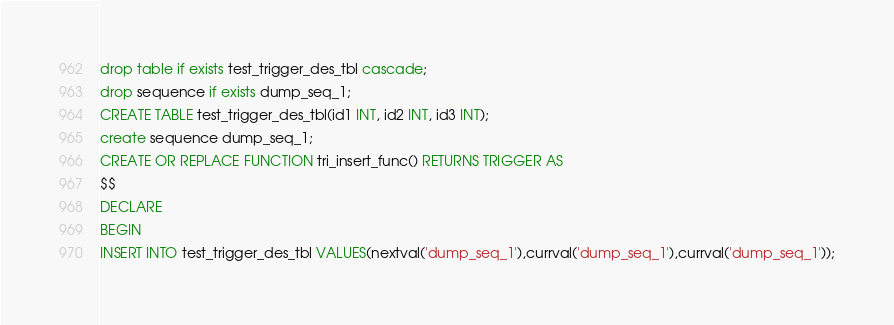Convert code to text. <code><loc_0><loc_0><loc_500><loc_500><_SQL_>drop table if exists test_trigger_des_tbl cascade;
drop sequence if exists dump_seq_1;
CREATE TABLE test_trigger_des_tbl(id1 INT, id2 INT, id3 INT);
create sequence dump_seq_1;
CREATE OR REPLACE FUNCTION tri_insert_func() RETURNS TRIGGER AS
$$
DECLARE
BEGIN
INSERT INTO test_trigger_des_tbl VALUES(nextval('dump_seq_1'),currval('dump_seq_1'),currval('dump_seq_1'));</code> 